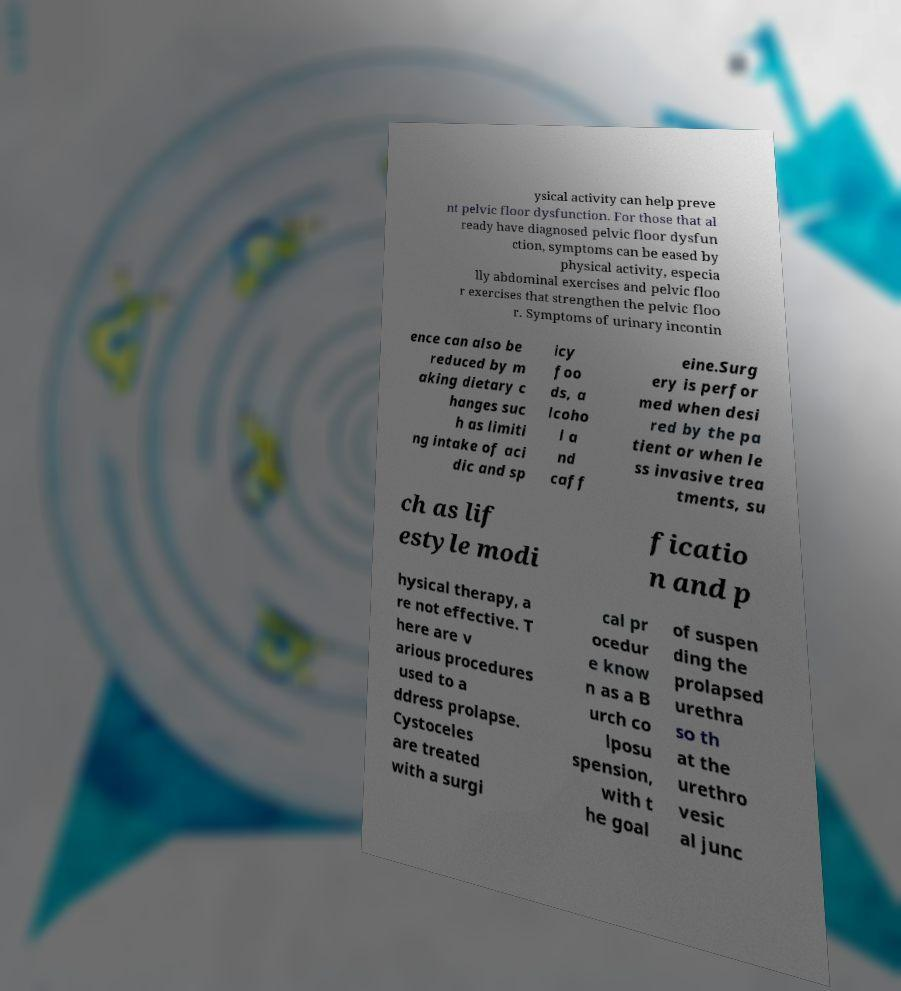Please identify and transcribe the text found in this image. ysical activity can help preve nt pelvic floor dysfunction. For those that al ready have diagnosed pelvic floor dysfun ction, symptoms can be eased by physical activity, especia lly abdominal exercises and pelvic floo r exercises that strengthen the pelvic floo r. Symptoms of urinary incontin ence can also be reduced by m aking dietary c hanges suc h as limiti ng intake of aci dic and sp icy foo ds, a lcoho l a nd caff eine.Surg ery is perfor med when desi red by the pa tient or when le ss invasive trea tments, su ch as lif estyle modi ficatio n and p hysical therapy, a re not effective. T here are v arious procedures used to a ddress prolapse. Cystoceles are treated with a surgi cal pr ocedur e know n as a B urch co lposu spension, with t he goal of suspen ding the prolapsed urethra so th at the urethro vesic al junc 